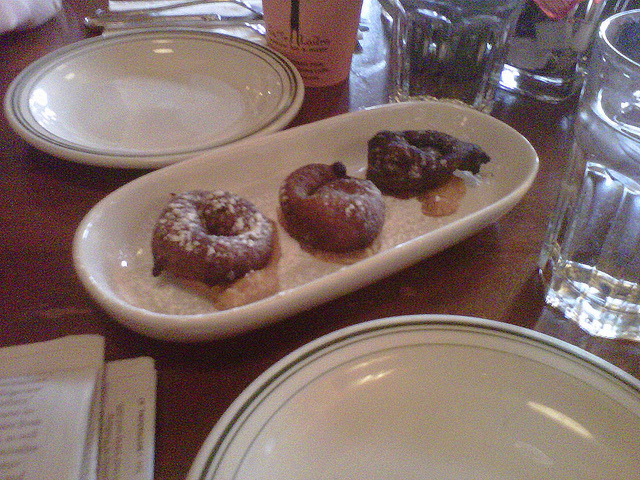How many donuts are there? There are three donuts visible on the plate, each with a distinct appearance suggesting a variety of flavors. 